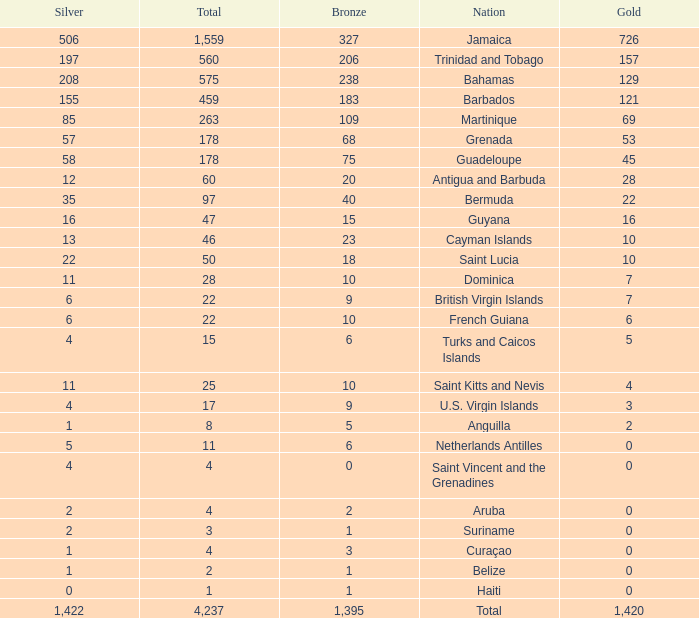What's the total number of Silver that has Gold that's larger than 0, Bronze that's smaller than 23, a Total that's larger than 22, and has the Nation of Saint Kitts and Nevis? 1.0. 